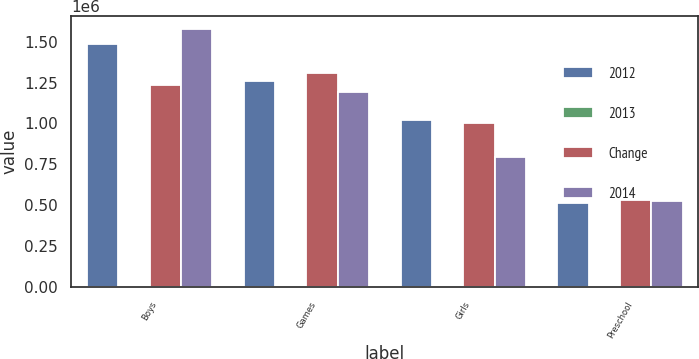Convert chart. <chart><loc_0><loc_0><loc_500><loc_500><stacked_bar_chart><ecel><fcel>Boys<fcel>Games<fcel>Girls<fcel>Preschool<nl><fcel>2012<fcel>1.48395e+06<fcel>1.25978e+06<fcel>1.02263e+06<fcel>510840<nl><fcel>2013<fcel>20<fcel>4<fcel>2<fcel>4<nl><fcel>Change<fcel>1.23761e+06<fcel>1.3112e+06<fcel>1.0017e+06<fcel>531637<nl><fcel>2014<fcel>1.57701e+06<fcel>1.19209e+06<fcel>792292<fcel>527591<nl></chart> 